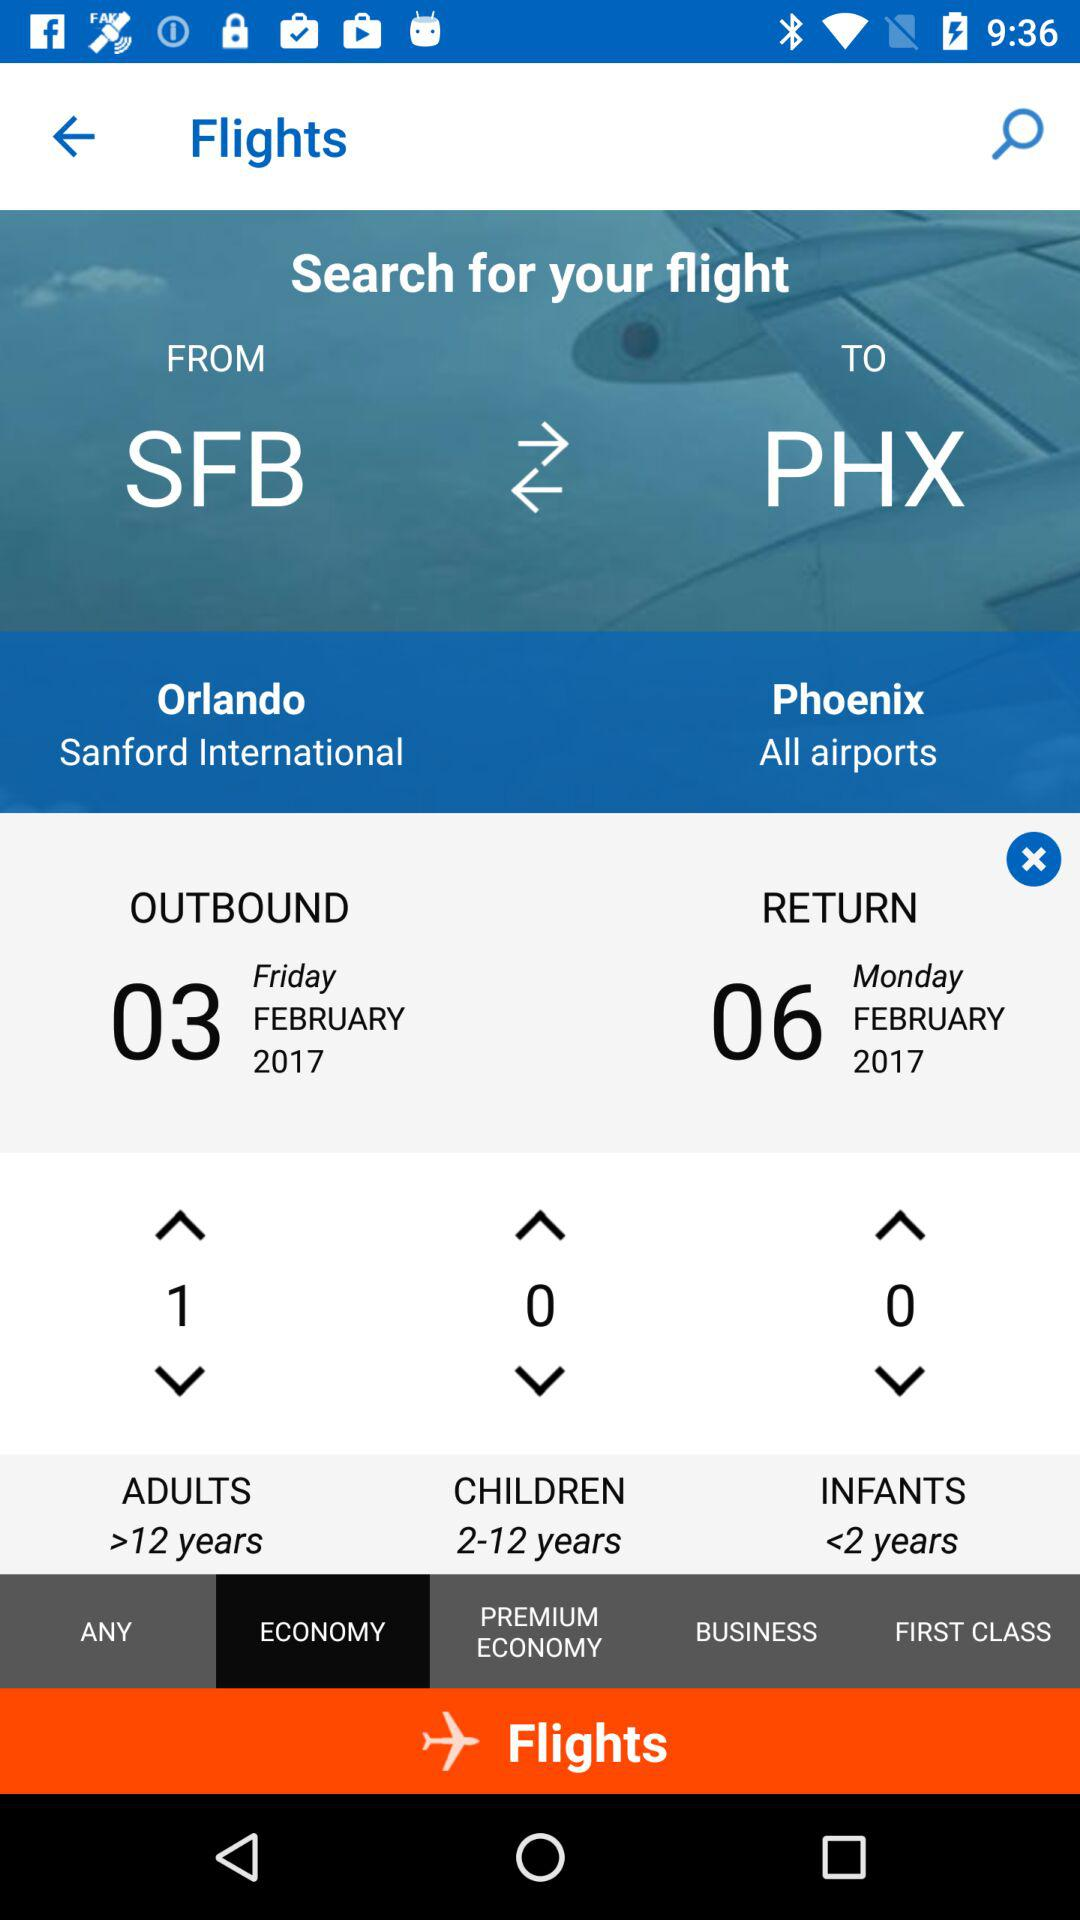How many adults are selected for the flight? The selected number of adults is 1. 